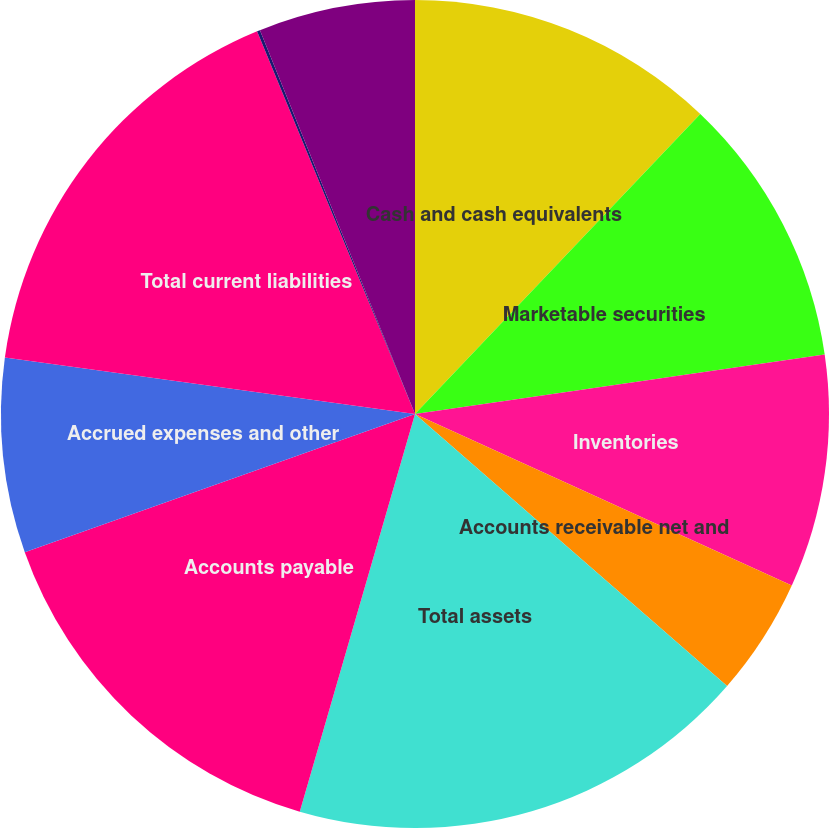Convert chart. <chart><loc_0><loc_0><loc_500><loc_500><pie_chart><fcel>Cash and cash equivalents<fcel>Marketable securities<fcel>Inventories<fcel>Accounts receivable net and<fcel>Total assets<fcel>Accounts payable<fcel>Accrued expenses and other<fcel>Total current liabilities<fcel>Long-term debt<fcel>Other long-term liabilities<nl><fcel>12.1%<fcel>10.6%<fcel>9.1%<fcel>4.61%<fcel>18.08%<fcel>15.09%<fcel>7.6%<fcel>16.59%<fcel>0.12%<fcel>6.11%<nl></chart> 